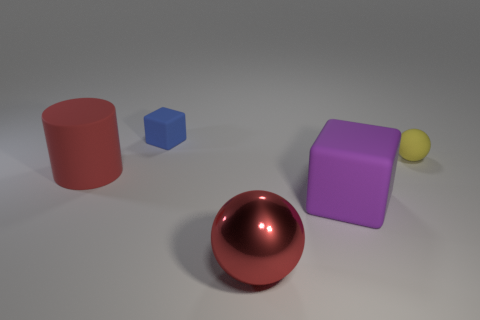Does the big shiny thing have the same color as the big cylinder left of the yellow matte thing?
Your answer should be compact. Yes. How big is the matte thing that is left of the large block and in front of the tiny matte cube?
Ensure brevity in your answer.  Large. What number of other things are there of the same color as the large cube?
Your answer should be very brief. 0. How big is the red object that is to the left of the matte cube to the left of the sphere left of the rubber ball?
Make the answer very short. Large. There is a rubber cylinder; are there any small blue rubber blocks right of it?
Offer a terse response. Yes. There is a purple cube; is it the same size as the matte block behind the purple rubber object?
Give a very brief answer. No. What number of other things are there of the same material as the purple object
Give a very brief answer. 3. What shape is the matte thing that is both behind the rubber cylinder and to the left of the red sphere?
Give a very brief answer. Cube. Does the rubber block that is on the right side of the large red shiny object have the same size as the cube that is behind the large red matte object?
Keep it short and to the point. No. What shape is the yellow object that is made of the same material as the small cube?
Offer a very short reply. Sphere. 